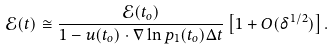<formula> <loc_0><loc_0><loc_500><loc_500>\mathcal { E } ( t ) \cong \frac { \mathcal { E } ( t _ { o } ) } { 1 - u ( t _ { o } ) \cdot \nabla \ln p _ { 1 } ( t _ { o } ) \Delta t } \left [ 1 + O ( \delta ^ { 1 / 2 } ) \right ] .</formula> 